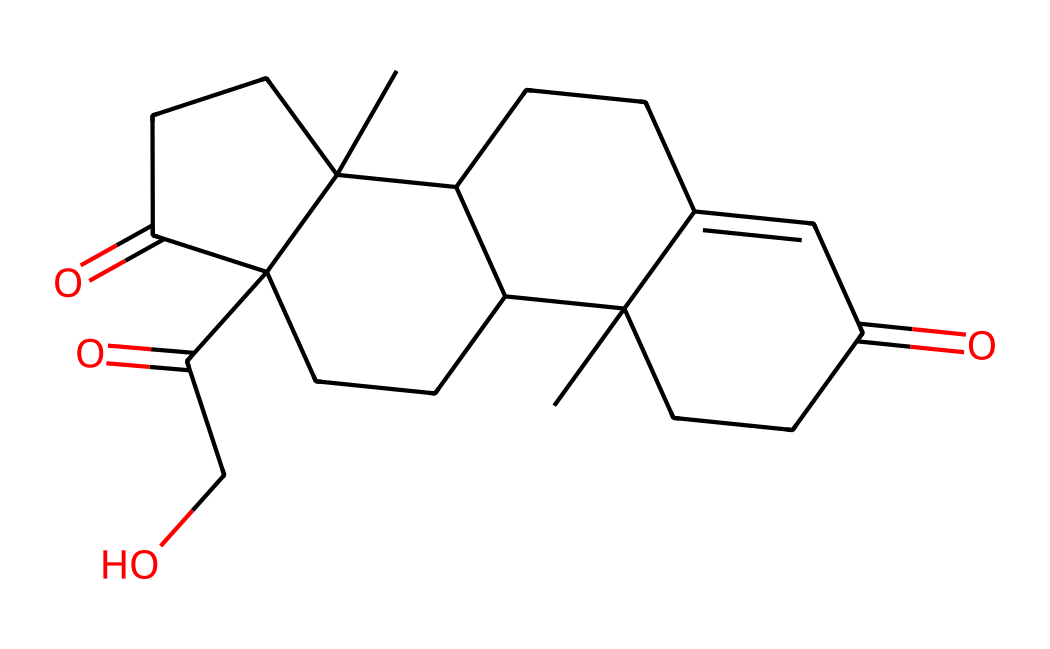What is the molecular formula of cortisone? To determine the molecular formula, we can count the number of carbon (C), hydrogen (H), and oxygen (O) atoms in the SMILES representation. The structure consists of 21 carbon atoms, 30 hydrogen atoms, and 5 oxygen atoms.
Answer: C21H30O5 How many double bonds are present in this molecule? By analyzing the SMILES, we can identify that there are two distinct instances where double bonds are indicated by the '=' sign. Therefore, there are two double bonds in cortisone.
Answer: 2 What functional groups are present in cortisone? Evaluating the structure, we can see that there are ketones (indicated by the carbonyl groups, C=O) and hydroxyl groups (indicated by the -OH group). Therefore, the main functional groups are ketones and alcohols.
Answer: ketones and alcohols Is cortisone a steroid? Examining the molecular structure reveals that cortisone has a characteristic steroid skeleton, which consists of four fused carbon rings. Hence, it confirms that cortisone is a steroid hormone.
Answer: yes What is the primary use of cortisone in sports medicine? Cortisone’s primary application is as an anti-inflammatory agent, utilized to reduce inflammation and alleviate pain in various sports injuries. This is due to its potent glucocorticoid properties.
Answer: anti-inflammatory Which part of the cortisone structure is responsible for its biological activity? The presence of the functional groups, particularly the hydroxyl (-OH) and ketone (C=O), influences the molecular interactions that confer biological activity. These functional groups are crucial for binding to specific receptors.
Answer: hydroxyl and ketone 